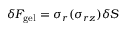Convert formula to latex. <formula><loc_0><loc_0><loc_500><loc_500>\delta F _ { g e l } = \sigma _ { r } ( \sigma _ { r z } ) \delta S</formula> 